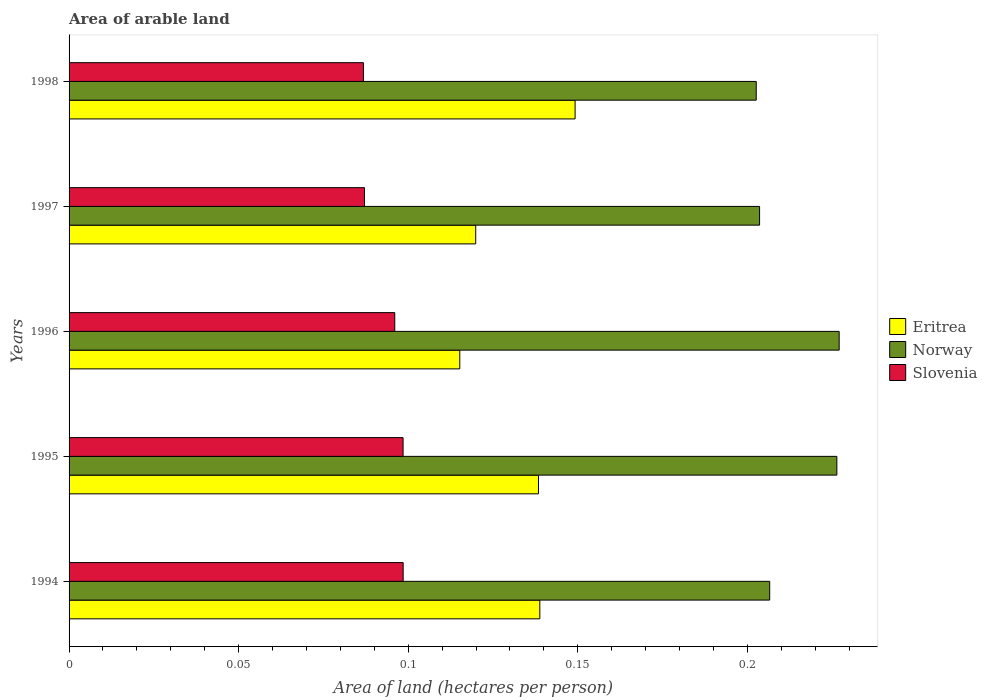How many different coloured bars are there?
Ensure brevity in your answer.  3. Are the number of bars per tick equal to the number of legend labels?
Ensure brevity in your answer.  Yes. Are the number of bars on each tick of the Y-axis equal?
Offer a very short reply. Yes. How many bars are there on the 5th tick from the top?
Your answer should be very brief. 3. What is the total arable land in Eritrea in 1998?
Offer a terse response. 0.15. Across all years, what is the maximum total arable land in Slovenia?
Provide a succinct answer. 0.1. Across all years, what is the minimum total arable land in Eritrea?
Make the answer very short. 0.12. In which year was the total arable land in Slovenia maximum?
Ensure brevity in your answer.  1994. What is the total total arable land in Norway in the graph?
Offer a very short reply. 1.07. What is the difference between the total arable land in Slovenia in 1994 and that in 1996?
Your answer should be compact. 0. What is the difference between the total arable land in Eritrea in 1996 and the total arable land in Slovenia in 1995?
Make the answer very short. 0.02. What is the average total arable land in Slovenia per year?
Keep it short and to the point. 0.09. In the year 1998, what is the difference between the total arable land in Slovenia and total arable land in Eritrea?
Offer a very short reply. -0.06. What is the ratio of the total arable land in Eritrea in 1995 to that in 1997?
Offer a terse response. 1.15. Is the difference between the total arable land in Slovenia in 1996 and 1998 greater than the difference between the total arable land in Eritrea in 1996 and 1998?
Ensure brevity in your answer.  Yes. What is the difference between the highest and the second highest total arable land in Norway?
Offer a terse response. 0. What is the difference between the highest and the lowest total arable land in Slovenia?
Your response must be concise. 0.01. Is the sum of the total arable land in Eritrea in 1994 and 1996 greater than the maximum total arable land in Norway across all years?
Offer a terse response. Yes. What does the 3rd bar from the top in 1998 represents?
Offer a very short reply. Eritrea. What does the 3rd bar from the bottom in 1995 represents?
Offer a terse response. Slovenia. How many years are there in the graph?
Your answer should be compact. 5. What is the difference between two consecutive major ticks on the X-axis?
Your answer should be compact. 0.05. Does the graph contain any zero values?
Give a very brief answer. No. Does the graph contain grids?
Your response must be concise. No. Where does the legend appear in the graph?
Give a very brief answer. Center right. How many legend labels are there?
Make the answer very short. 3. How are the legend labels stacked?
Your answer should be compact. Vertical. What is the title of the graph?
Your answer should be very brief. Area of arable land. What is the label or title of the X-axis?
Your answer should be very brief. Area of land (hectares per person). What is the label or title of the Y-axis?
Ensure brevity in your answer.  Years. What is the Area of land (hectares per person) in Eritrea in 1994?
Offer a very short reply. 0.14. What is the Area of land (hectares per person) in Norway in 1994?
Your answer should be very brief. 0.21. What is the Area of land (hectares per person) in Slovenia in 1994?
Give a very brief answer. 0.1. What is the Area of land (hectares per person) in Eritrea in 1995?
Your answer should be compact. 0.14. What is the Area of land (hectares per person) of Norway in 1995?
Make the answer very short. 0.23. What is the Area of land (hectares per person) of Slovenia in 1995?
Provide a succinct answer. 0.1. What is the Area of land (hectares per person) in Eritrea in 1996?
Offer a very short reply. 0.12. What is the Area of land (hectares per person) in Norway in 1996?
Give a very brief answer. 0.23. What is the Area of land (hectares per person) of Slovenia in 1996?
Your answer should be very brief. 0.1. What is the Area of land (hectares per person) of Eritrea in 1997?
Your answer should be very brief. 0.12. What is the Area of land (hectares per person) of Norway in 1997?
Make the answer very short. 0.2. What is the Area of land (hectares per person) of Slovenia in 1997?
Offer a terse response. 0.09. What is the Area of land (hectares per person) of Eritrea in 1998?
Give a very brief answer. 0.15. What is the Area of land (hectares per person) of Norway in 1998?
Make the answer very short. 0.2. What is the Area of land (hectares per person) in Slovenia in 1998?
Keep it short and to the point. 0.09. Across all years, what is the maximum Area of land (hectares per person) of Eritrea?
Your response must be concise. 0.15. Across all years, what is the maximum Area of land (hectares per person) in Norway?
Your response must be concise. 0.23. Across all years, what is the maximum Area of land (hectares per person) in Slovenia?
Ensure brevity in your answer.  0.1. Across all years, what is the minimum Area of land (hectares per person) of Eritrea?
Ensure brevity in your answer.  0.12. Across all years, what is the minimum Area of land (hectares per person) of Norway?
Your response must be concise. 0.2. Across all years, what is the minimum Area of land (hectares per person) of Slovenia?
Your answer should be very brief. 0.09. What is the total Area of land (hectares per person) of Eritrea in the graph?
Offer a very short reply. 0.66. What is the total Area of land (hectares per person) of Norway in the graph?
Your response must be concise. 1.07. What is the total Area of land (hectares per person) in Slovenia in the graph?
Give a very brief answer. 0.47. What is the difference between the Area of land (hectares per person) in Norway in 1994 and that in 1995?
Give a very brief answer. -0.02. What is the difference between the Area of land (hectares per person) of Eritrea in 1994 and that in 1996?
Offer a very short reply. 0.02. What is the difference between the Area of land (hectares per person) of Norway in 1994 and that in 1996?
Give a very brief answer. -0.02. What is the difference between the Area of land (hectares per person) in Slovenia in 1994 and that in 1996?
Provide a succinct answer. 0. What is the difference between the Area of land (hectares per person) in Eritrea in 1994 and that in 1997?
Provide a succinct answer. 0.02. What is the difference between the Area of land (hectares per person) of Norway in 1994 and that in 1997?
Ensure brevity in your answer.  0. What is the difference between the Area of land (hectares per person) in Slovenia in 1994 and that in 1997?
Offer a terse response. 0.01. What is the difference between the Area of land (hectares per person) in Eritrea in 1994 and that in 1998?
Offer a terse response. -0.01. What is the difference between the Area of land (hectares per person) of Norway in 1994 and that in 1998?
Offer a terse response. 0. What is the difference between the Area of land (hectares per person) in Slovenia in 1994 and that in 1998?
Offer a terse response. 0.01. What is the difference between the Area of land (hectares per person) of Eritrea in 1995 and that in 1996?
Give a very brief answer. 0.02. What is the difference between the Area of land (hectares per person) of Norway in 1995 and that in 1996?
Give a very brief answer. -0. What is the difference between the Area of land (hectares per person) of Slovenia in 1995 and that in 1996?
Your response must be concise. 0. What is the difference between the Area of land (hectares per person) of Eritrea in 1995 and that in 1997?
Offer a terse response. 0.02. What is the difference between the Area of land (hectares per person) of Norway in 1995 and that in 1997?
Your response must be concise. 0.02. What is the difference between the Area of land (hectares per person) in Slovenia in 1995 and that in 1997?
Give a very brief answer. 0.01. What is the difference between the Area of land (hectares per person) of Eritrea in 1995 and that in 1998?
Make the answer very short. -0.01. What is the difference between the Area of land (hectares per person) of Norway in 1995 and that in 1998?
Give a very brief answer. 0.02. What is the difference between the Area of land (hectares per person) in Slovenia in 1995 and that in 1998?
Make the answer very short. 0.01. What is the difference between the Area of land (hectares per person) of Eritrea in 1996 and that in 1997?
Offer a very short reply. -0. What is the difference between the Area of land (hectares per person) of Norway in 1996 and that in 1997?
Give a very brief answer. 0.02. What is the difference between the Area of land (hectares per person) of Slovenia in 1996 and that in 1997?
Keep it short and to the point. 0.01. What is the difference between the Area of land (hectares per person) of Eritrea in 1996 and that in 1998?
Your answer should be compact. -0.03. What is the difference between the Area of land (hectares per person) of Norway in 1996 and that in 1998?
Offer a terse response. 0.02. What is the difference between the Area of land (hectares per person) in Slovenia in 1996 and that in 1998?
Provide a short and direct response. 0.01. What is the difference between the Area of land (hectares per person) in Eritrea in 1997 and that in 1998?
Your answer should be compact. -0.03. What is the difference between the Area of land (hectares per person) in Slovenia in 1997 and that in 1998?
Offer a very short reply. 0. What is the difference between the Area of land (hectares per person) of Eritrea in 1994 and the Area of land (hectares per person) of Norway in 1995?
Offer a very short reply. -0.09. What is the difference between the Area of land (hectares per person) in Eritrea in 1994 and the Area of land (hectares per person) in Slovenia in 1995?
Provide a succinct answer. 0.04. What is the difference between the Area of land (hectares per person) of Norway in 1994 and the Area of land (hectares per person) of Slovenia in 1995?
Make the answer very short. 0.11. What is the difference between the Area of land (hectares per person) of Eritrea in 1994 and the Area of land (hectares per person) of Norway in 1996?
Give a very brief answer. -0.09. What is the difference between the Area of land (hectares per person) of Eritrea in 1994 and the Area of land (hectares per person) of Slovenia in 1996?
Keep it short and to the point. 0.04. What is the difference between the Area of land (hectares per person) of Norway in 1994 and the Area of land (hectares per person) of Slovenia in 1996?
Give a very brief answer. 0.11. What is the difference between the Area of land (hectares per person) in Eritrea in 1994 and the Area of land (hectares per person) in Norway in 1997?
Offer a very short reply. -0.06. What is the difference between the Area of land (hectares per person) of Eritrea in 1994 and the Area of land (hectares per person) of Slovenia in 1997?
Make the answer very short. 0.05. What is the difference between the Area of land (hectares per person) in Norway in 1994 and the Area of land (hectares per person) in Slovenia in 1997?
Ensure brevity in your answer.  0.12. What is the difference between the Area of land (hectares per person) of Eritrea in 1994 and the Area of land (hectares per person) of Norway in 1998?
Your answer should be very brief. -0.06. What is the difference between the Area of land (hectares per person) in Eritrea in 1994 and the Area of land (hectares per person) in Slovenia in 1998?
Your answer should be very brief. 0.05. What is the difference between the Area of land (hectares per person) in Norway in 1994 and the Area of land (hectares per person) in Slovenia in 1998?
Your answer should be very brief. 0.12. What is the difference between the Area of land (hectares per person) of Eritrea in 1995 and the Area of land (hectares per person) of Norway in 1996?
Give a very brief answer. -0.09. What is the difference between the Area of land (hectares per person) of Eritrea in 1995 and the Area of land (hectares per person) of Slovenia in 1996?
Offer a terse response. 0.04. What is the difference between the Area of land (hectares per person) of Norway in 1995 and the Area of land (hectares per person) of Slovenia in 1996?
Keep it short and to the point. 0.13. What is the difference between the Area of land (hectares per person) in Eritrea in 1995 and the Area of land (hectares per person) in Norway in 1997?
Give a very brief answer. -0.07. What is the difference between the Area of land (hectares per person) of Eritrea in 1995 and the Area of land (hectares per person) of Slovenia in 1997?
Keep it short and to the point. 0.05. What is the difference between the Area of land (hectares per person) of Norway in 1995 and the Area of land (hectares per person) of Slovenia in 1997?
Ensure brevity in your answer.  0.14. What is the difference between the Area of land (hectares per person) of Eritrea in 1995 and the Area of land (hectares per person) of Norway in 1998?
Your response must be concise. -0.06. What is the difference between the Area of land (hectares per person) in Eritrea in 1995 and the Area of land (hectares per person) in Slovenia in 1998?
Keep it short and to the point. 0.05. What is the difference between the Area of land (hectares per person) in Norway in 1995 and the Area of land (hectares per person) in Slovenia in 1998?
Your answer should be very brief. 0.14. What is the difference between the Area of land (hectares per person) of Eritrea in 1996 and the Area of land (hectares per person) of Norway in 1997?
Provide a short and direct response. -0.09. What is the difference between the Area of land (hectares per person) of Eritrea in 1996 and the Area of land (hectares per person) of Slovenia in 1997?
Make the answer very short. 0.03. What is the difference between the Area of land (hectares per person) of Norway in 1996 and the Area of land (hectares per person) of Slovenia in 1997?
Provide a succinct answer. 0.14. What is the difference between the Area of land (hectares per person) in Eritrea in 1996 and the Area of land (hectares per person) in Norway in 1998?
Your answer should be very brief. -0.09. What is the difference between the Area of land (hectares per person) of Eritrea in 1996 and the Area of land (hectares per person) of Slovenia in 1998?
Your response must be concise. 0.03. What is the difference between the Area of land (hectares per person) of Norway in 1996 and the Area of land (hectares per person) of Slovenia in 1998?
Your response must be concise. 0.14. What is the difference between the Area of land (hectares per person) in Eritrea in 1997 and the Area of land (hectares per person) in Norway in 1998?
Your answer should be compact. -0.08. What is the difference between the Area of land (hectares per person) in Eritrea in 1997 and the Area of land (hectares per person) in Slovenia in 1998?
Ensure brevity in your answer.  0.03. What is the difference between the Area of land (hectares per person) in Norway in 1997 and the Area of land (hectares per person) in Slovenia in 1998?
Your answer should be compact. 0.12. What is the average Area of land (hectares per person) in Eritrea per year?
Your answer should be compact. 0.13. What is the average Area of land (hectares per person) of Norway per year?
Offer a terse response. 0.21. What is the average Area of land (hectares per person) in Slovenia per year?
Provide a short and direct response. 0.09. In the year 1994, what is the difference between the Area of land (hectares per person) in Eritrea and Area of land (hectares per person) in Norway?
Make the answer very short. -0.07. In the year 1994, what is the difference between the Area of land (hectares per person) in Eritrea and Area of land (hectares per person) in Slovenia?
Ensure brevity in your answer.  0.04. In the year 1994, what is the difference between the Area of land (hectares per person) in Norway and Area of land (hectares per person) in Slovenia?
Provide a short and direct response. 0.11. In the year 1995, what is the difference between the Area of land (hectares per person) of Eritrea and Area of land (hectares per person) of Norway?
Offer a very short reply. -0.09. In the year 1995, what is the difference between the Area of land (hectares per person) of Eritrea and Area of land (hectares per person) of Slovenia?
Provide a short and direct response. 0.04. In the year 1995, what is the difference between the Area of land (hectares per person) of Norway and Area of land (hectares per person) of Slovenia?
Provide a short and direct response. 0.13. In the year 1996, what is the difference between the Area of land (hectares per person) in Eritrea and Area of land (hectares per person) in Norway?
Make the answer very short. -0.11. In the year 1996, what is the difference between the Area of land (hectares per person) of Eritrea and Area of land (hectares per person) of Slovenia?
Keep it short and to the point. 0.02. In the year 1996, what is the difference between the Area of land (hectares per person) in Norway and Area of land (hectares per person) in Slovenia?
Offer a very short reply. 0.13. In the year 1997, what is the difference between the Area of land (hectares per person) of Eritrea and Area of land (hectares per person) of Norway?
Your response must be concise. -0.08. In the year 1997, what is the difference between the Area of land (hectares per person) in Eritrea and Area of land (hectares per person) in Slovenia?
Offer a very short reply. 0.03. In the year 1997, what is the difference between the Area of land (hectares per person) of Norway and Area of land (hectares per person) of Slovenia?
Offer a terse response. 0.12. In the year 1998, what is the difference between the Area of land (hectares per person) of Eritrea and Area of land (hectares per person) of Norway?
Provide a succinct answer. -0.05. In the year 1998, what is the difference between the Area of land (hectares per person) in Eritrea and Area of land (hectares per person) in Slovenia?
Offer a very short reply. 0.06. In the year 1998, what is the difference between the Area of land (hectares per person) of Norway and Area of land (hectares per person) of Slovenia?
Offer a terse response. 0.12. What is the ratio of the Area of land (hectares per person) of Norway in 1994 to that in 1995?
Keep it short and to the point. 0.91. What is the ratio of the Area of land (hectares per person) in Eritrea in 1994 to that in 1996?
Your answer should be compact. 1.2. What is the ratio of the Area of land (hectares per person) of Norway in 1994 to that in 1996?
Your response must be concise. 0.91. What is the ratio of the Area of land (hectares per person) of Slovenia in 1994 to that in 1996?
Your response must be concise. 1.03. What is the ratio of the Area of land (hectares per person) of Eritrea in 1994 to that in 1997?
Keep it short and to the point. 1.16. What is the ratio of the Area of land (hectares per person) in Norway in 1994 to that in 1997?
Your answer should be compact. 1.01. What is the ratio of the Area of land (hectares per person) in Slovenia in 1994 to that in 1997?
Offer a very short reply. 1.13. What is the ratio of the Area of land (hectares per person) of Eritrea in 1994 to that in 1998?
Your answer should be compact. 0.93. What is the ratio of the Area of land (hectares per person) in Norway in 1994 to that in 1998?
Your answer should be very brief. 1.02. What is the ratio of the Area of land (hectares per person) in Slovenia in 1994 to that in 1998?
Provide a short and direct response. 1.14. What is the ratio of the Area of land (hectares per person) in Eritrea in 1995 to that in 1996?
Your answer should be compact. 1.2. What is the ratio of the Area of land (hectares per person) of Norway in 1995 to that in 1996?
Make the answer very short. 1. What is the ratio of the Area of land (hectares per person) in Slovenia in 1995 to that in 1996?
Your answer should be very brief. 1.03. What is the ratio of the Area of land (hectares per person) in Eritrea in 1995 to that in 1997?
Offer a terse response. 1.15. What is the ratio of the Area of land (hectares per person) in Norway in 1995 to that in 1997?
Give a very brief answer. 1.11. What is the ratio of the Area of land (hectares per person) in Slovenia in 1995 to that in 1997?
Give a very brief answer. 1.13. What is the ratio of the Area of land (hectares per person) in Eritrea in 1995 to that in 1998?
Provide a short and direct response. 0.93. What is the ratio of the Area of land (hectares per person) of Norway in 1995 to that in 1998?
Your answer should be compact. 1.12. What is the ratio of the Area of land (hectares per person) in Slovenia in 1995 to that in 1998?
Keep it short and to the point. 1.13. What is the ratio of the Area of land (hectares per person) of Eritrea in 1996 to that in 1997?
Offer a terse response. 0.96. What is the ratio of the Area of land (hectares per person) of Norway in 1996 to that in 1997?
Provide a succinct answer. 1.12. What is the ratio of the Area of land (hectares per person) in Slovenia in 1996 to that in 1997?
Your response must be concise. 1.1. What is the ratio of the Area of land (hectares per person) of Eritrea in 1996 to that in 1998?
Offer a very short reply. 0.77. What is the ratio of the Area of land (hectares per person) of Norway in 1996 to that in 1998?
Provide a succinct answer. 1.12. What is the ratio of the Area of land (hectares per person) in Slovenia in 1996 to that in 1998?
Your answer should be very brief. 1.11. What is the ratio of the Area of land (hectares per person) in Eritrea in 1997 to that in 1998?
Your answer should be very brief. 0.8. What is the difference between the highest and the second highest Area of land (hectares per person) of Eritrea?
Offer a terse response. 0.01. What is the difference between the highest and the second highest Area of land (hectares per person) in Norway?
Your response must be concise. 0. What is the difference between the highest and the second highest Area of land (hectares per person) of Slovenia?
Provide a short and direct response. 0. What is the difference between the highest and the lowest Area of land (hectares per person) in Eritrea?
Provide a short and direct response. 0.03. What is the difference between the highest and the lowest Area of land (hectares per person) in Norway?
Your response must be concise. 0.02. What is the difference between the highest and the lowest Area of land (hectares per person) of Slovenia?
Your response must be concise. 0.01. 